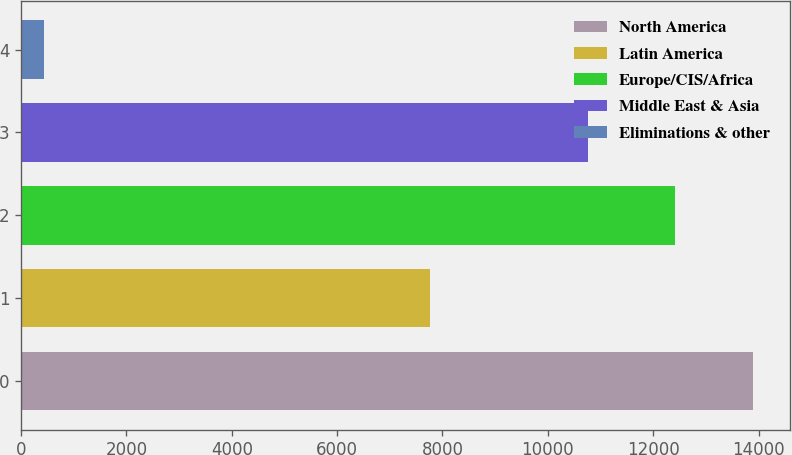Convert chart. <chart><loc_0><loc_0><loc_500><loc_500><bar_chart><fcel>North America<fcel>Latin America<fcel>Europe/CIS/Africa<fcel>Middle East & Asia<fcel>Eliminations & other<nl><fcel>13897<fcel>7754<fcel>12411<fcel>10767<fcel>437<nl></chart> 